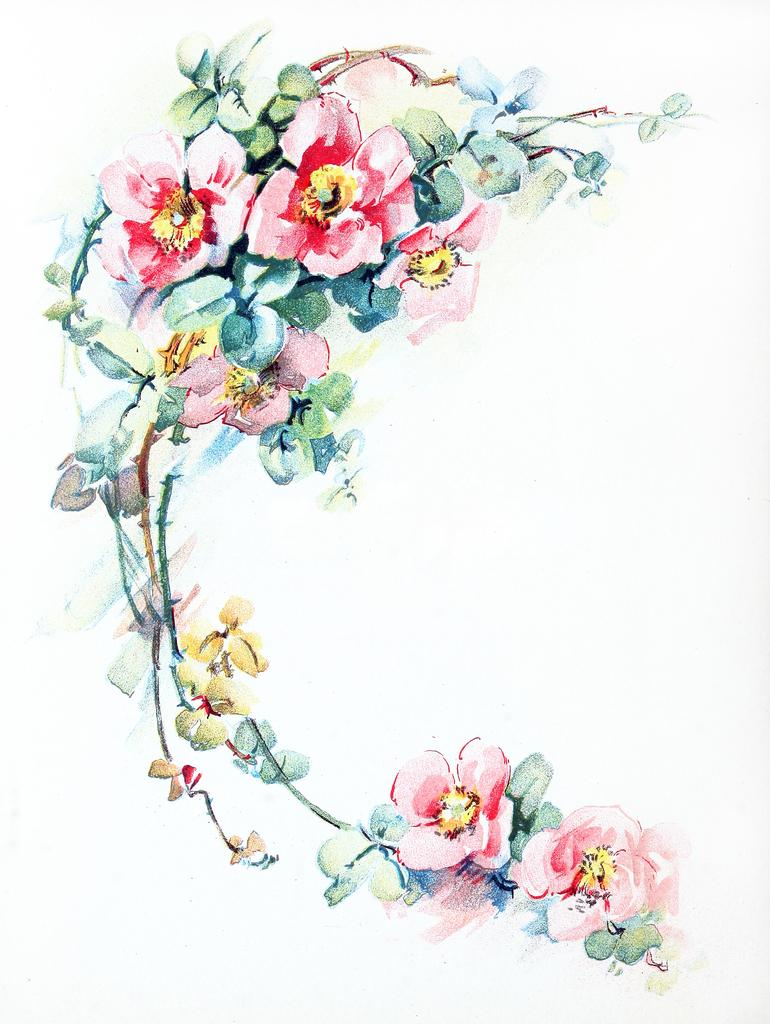What is the main subject of the image? There is a painting in the image. What is the background color of the surface on which the painting is displayed? The painting is on a white surface. What is the theme of the painting? The painting depicts flowers. What colors are used to paint the flowers in the image? The flowers are in pink, red, green, and yellow colors. How many bags can be seen hanging from the rail in the image? There is no rail or bags present in the image; it features a painting of flowers on a white surface. 